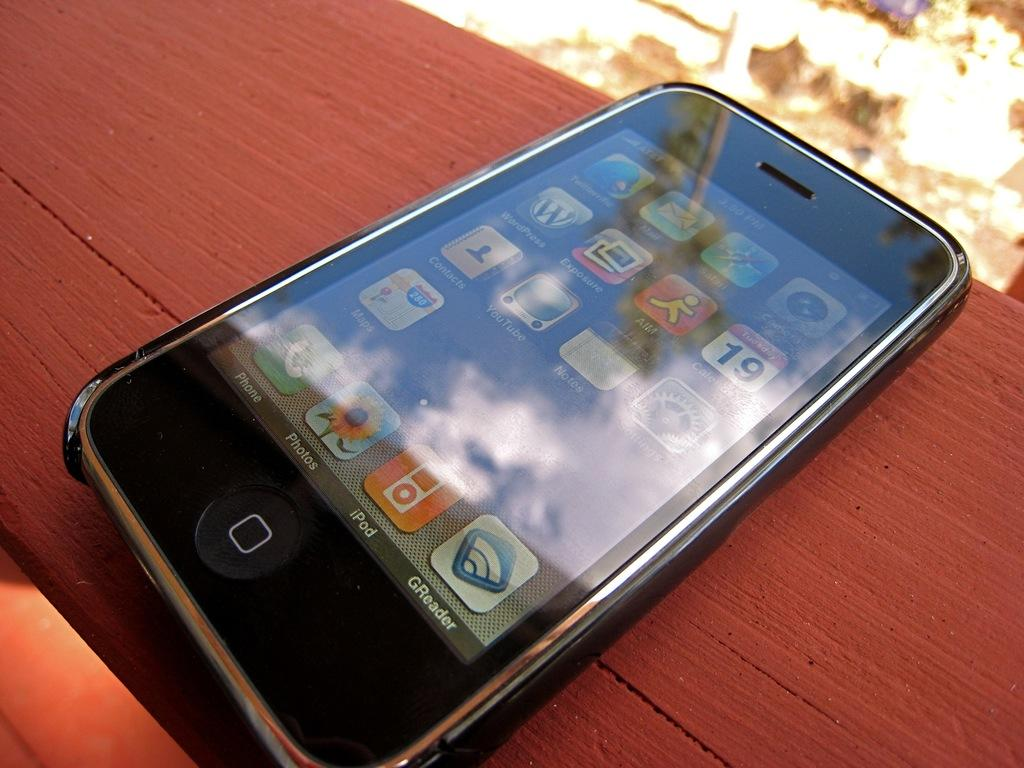<image>
Relay a brief, clear account of the picture shown. an iphone screen that is turned on and shows the photos app 